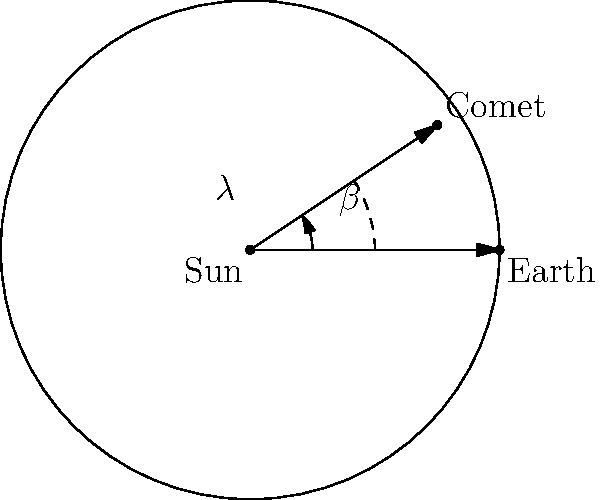Given a comet's ecliptic coordinates $\lambda = 60°$ (ecliptic longitude) and $\beta = 30°$ (ecliptic latitude), and its distance from the Sun $r = 2$ AU, estimate its size and mass assuming it's a spherical object with a density of 0.6 g/cm³. How would this information impact your emergency response plan? To estimate the comet's size and mass, we'll follow these steps:

1. Convert the comet's position to Cartesian coordinates:
   $x = r \cos\beta \cos\lambda = 2 \cdot \cos(30°) \cdot \cos(60°) = 0.866$ AU
   $y = r \cos\beta \sin\lambda = 2 \cdot \cos(30°) \cdot \sin(60°) = 1.5$ AU
   $z = r \sin\beta = 2 \cdot \sin(30°) = 1$ AU

2. Calculate the comet's distance from Earth:
   $d_E = \sqrt{(x-1)^2 + y^2 + z^2} = \sqrt{(-0.134)^2 + 1.5^2 + 1^2} = 1.816$ AU

3. Assume the comet's absolute magnitude $H = 10$ (typical for medium-sized comets).

4. Use the magnitude equation to estimate the comet's diameter:
   $H = 5 \log_{10}(1329 \cdot 10^{-\frac{V}{5}}/D)$
   where $V = H + 5 \log_{10}(d_E \cdot r)$
   
   Solving for $D$: $D \approx 10$ km

5. Calculate the comet's volume:
   $V = \frac{4}{3}\pi r^3 = \frac{4}{3}\pi (5000\text{ m})^3 = 5.24 \times 10^{11}$ m³

6. Calculate the comet's mass using the given density:
   $M = \rho V = 600 \text{ kg/m³} \cdot 5.24 \times 10^{11} \text{ m³} = 3.14 \times 10^{14}$ kg

This information impacts the emergency response plan by:
1. Determining the potential impact energy
2. Estimating the size of the affected area
3. Assessing the need for evacuation or other protective measures
4. Planning for potential atmospheric effects or tsunamis
Answer: Diameter ≈ 10 km, Mass ≈ 3.14 × 10¹⁴ kg 